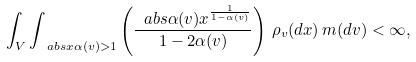<formula> <loc_0><loc_0><loc_500><loc_500>\int _ { V } \int _ { \ a b s { x \alpha ( v ) } > 1 } \left ( \frac { \ a b s { \alpha ( v ) x } ^ { \frac { 1 } { 1 - \alpha ( v ) } } } { 1 - 2 \alpha ( v ) } \right ) \, \rho _ { v } ( d x ) \, m ( d v ) < \infty ,</formula> 